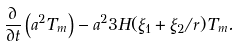Convert formula to latex. <formula><loc_0><loc_0><loc_500><loc_500>\frac { \partial } { \partial t } \left ( a ^ { 2 } T _ { m } \right ) - a ^ { 2 } 3 H ( \xi _ { 1 } + \xi _ { 2 } / r ) T _ { m } .</formula> 